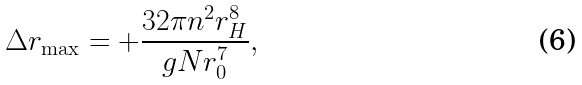<formula> <loc_0><loc_0><loc_500><loc_500>\Delta r _ { \max } = + \frac { 3 2 \pi n ^ { 2 } r _ { H } ^ { 8 } } { g N r _ { 0 } ^ { 7 } } ,</formula> 